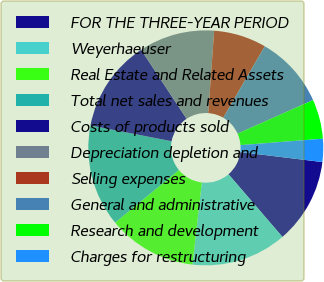Convert chart to OTSL. <chart><loc_0><loc_0><loc_500><loc_500><pie_chart><fcel>FOR THE THREE-YEAR PERIOD<fcel>Weyerhaeuser<fcel>Real Estate and Related Assets<fcel>Total net sales and revenues<fcel>Costs of products sold<fcel>Depreciation depletion and<fcel>Selling expenses<fcel>General and administrative<fcel>Research and development<fcel>Charges for restructuring<nl><fcel>11.76%<fcel>13.12%<fcel>12.22%<fcel>14.03%<fcel>12.67%<fcel>10.41%<fcel>7.24%<fcel>9.95%<fcel>5.43%<fcel>3.17%<nl></chart> 